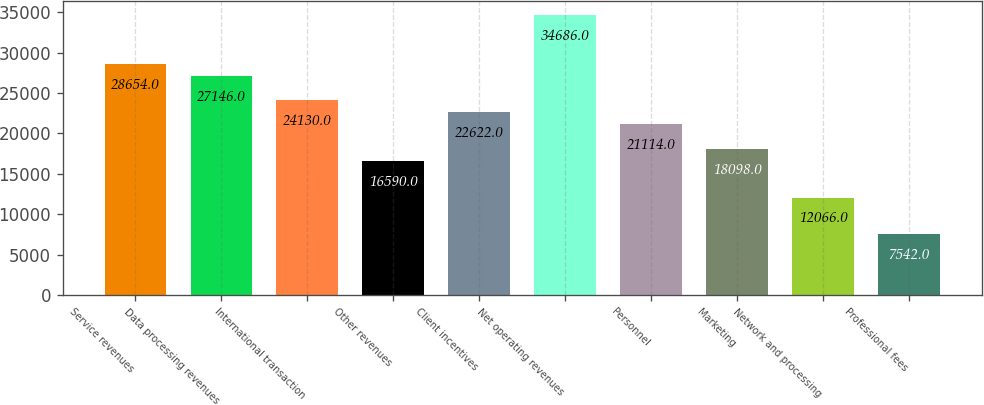Convert chart to OTSL. <chart><loc_0><loc_0><loc_500><loc_500><bar_chart><fcel>Service revenues<fcel>Data processing revenues<fcel>International transaction<fcel>Other revenues<fcel>Client incentives<fcel>Net operating revenues<fcel>Personnel<fcel>Marketing<fcel>Network and processing<fcel>Professional fees<nl><fcel>28654<fcel>27146<fcel>24130<fcel>16590<fcel>22622<fcel>34686<fcel>21114<fcel>18098<fcel>12066<fcel>7542<nl></chart> 